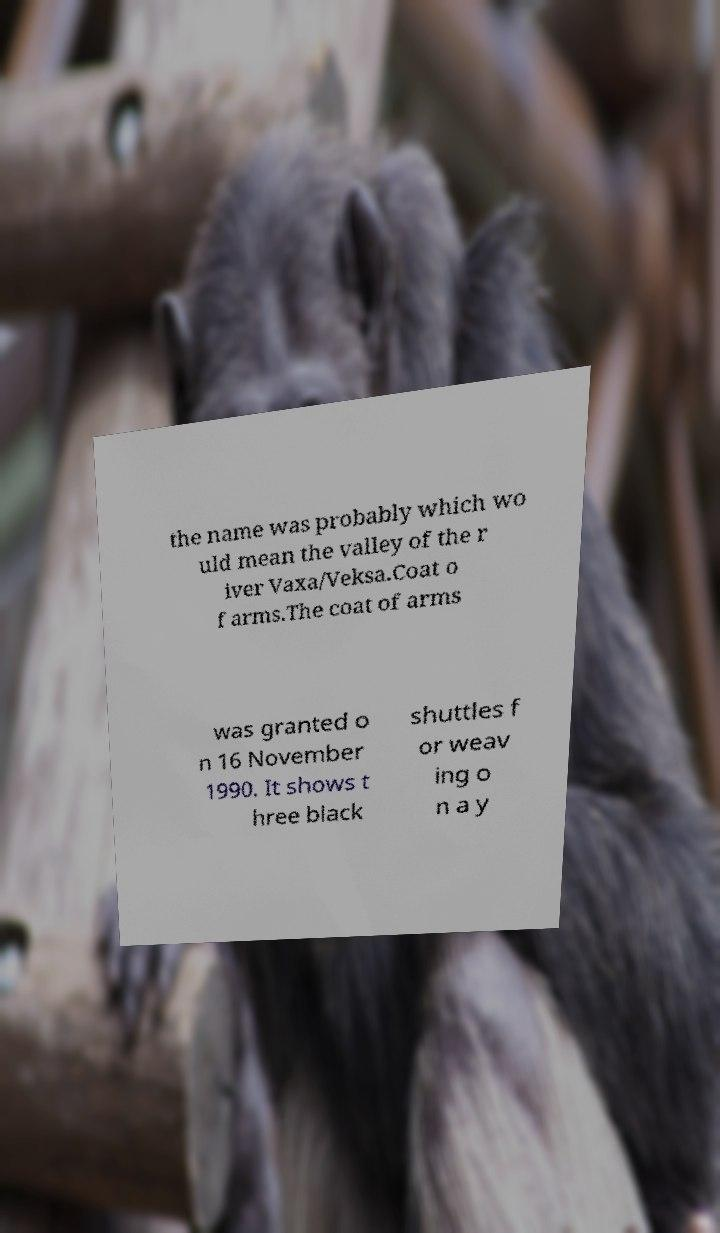Please identify and transcribe the text found in this image. the name was probably which wo uld mean the valley of the r iver Vaxa/Veksa.Coat o f arms.The coat of arms was granted o n 16 November 1990. It shows t hree black shuttles f or weav ing o n a y 